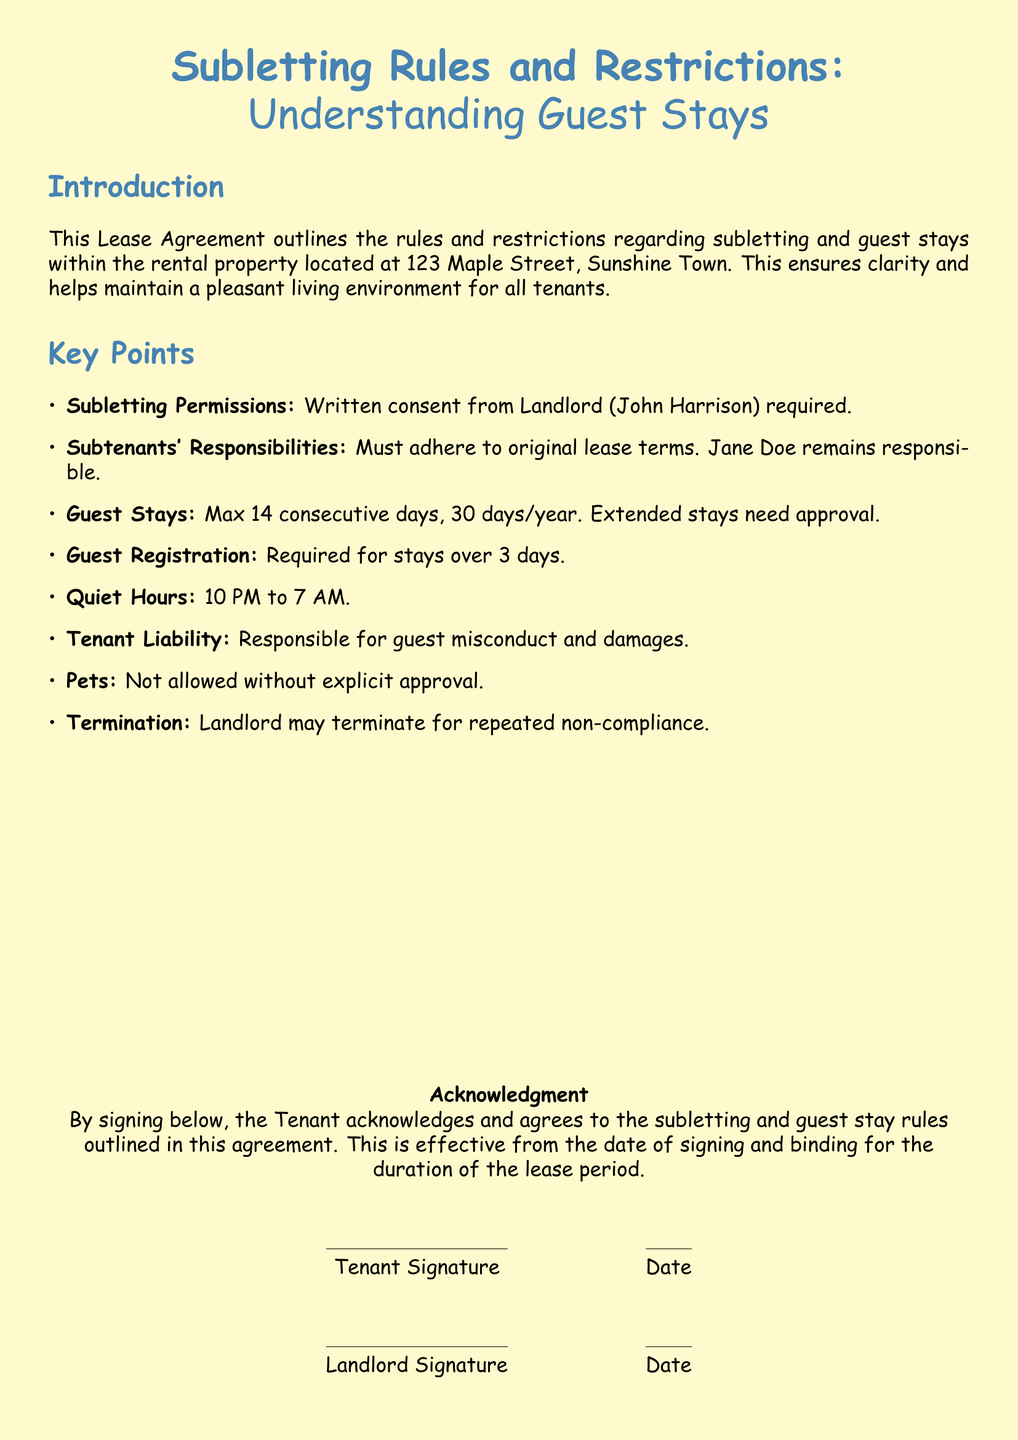What is the address of the rental property? The address is specified in the introduction section of the document as 123 Maple Street, Sunshine Town.
Answer: 123 Maple Street, Sunshine Town Who is the landlord? The landlord's name is mentioned in the key points section, which states John Harrison as the landlord.
Answer: John Harrison What is the maximum duration for consecutive guest stays? The document indicates the maximum duration for guest stays is mentioned in the key points section as 14 consecutive days.
Answer: 14 consecutive days How many days per year are guests allowed to stay? The document specifies the number of days allowed for guest stays in the key points, which is 30 days per year.
Answer: 30 days/year What is required for guest stays longer than 3 days? The document mentions that guest registration is required for stays over 3 days, which highlights a specific rule for longer stays.
Answer: Guest registration What hours are designated as quiet hours? The quiet hours are defined in the key points, indicating the time frame tenants must adhere to during which noise should be minimized.
Answer: 10 PM to 7 AM What happens if there is repeated non-compliance? The document states that the landlord may terminate the lease for repeated non-compliance, identifying a consequence for not following the rules.
Answer: Termination Who retains responsibility for the subtenants' actions? The responsibilities concerning subtenants are outlined, stating that Jane Doe remains responsible for all actions of subtenants.
Answer: Jane Doe Are pets allowed without approval? The key points outline a restriction regarding pets, which indicates that explicit approval is necessary for any pets to be allowed.
Answer: Not allowed without explicit approval 